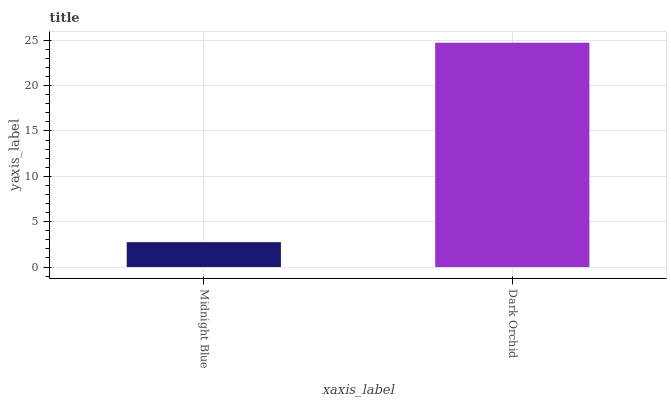Is Midnight Blue the minimum?
Answer yes or no. Yes. Is Dark Orchid the maximum?
Answer yes or no. Yes. Is Dark Orchid the minimum?
Answer yes or no. No. Is Dark Orchid greater than Midnight Blue?
Answer yes or no. Yes. Is Midnight Blue less than Dark Orchid?
Answer yes or no. Yes. Is Midnight Blue greater than Dark Orchid?
Answer yes or no. No. Is Dark Orchid less than Midnight Blue?
Answer yes or no. No. Is Dark Orchid the high median?
Answer yes or no. Yes. Is Midnight Blue the low median?
Answer yes or no. Yes. Is Midnight Blue the high median?
Answer yes or no. No. Is Dark Orchid the low median?
Answer yes or no. No. 